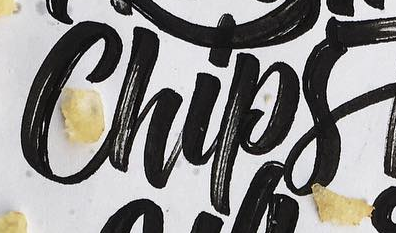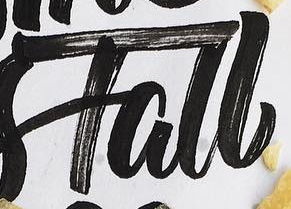What text appears in these images from left to right, separated by a semicolon? Chips; Tall 